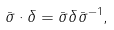<formula> <loc_0><loc_0><loc_500><loc_500>\bar { \sigma } \cdot \delta = \bar { \sigma } \delta \bar { \sigma } ^ { - 1 } ,</formula> 